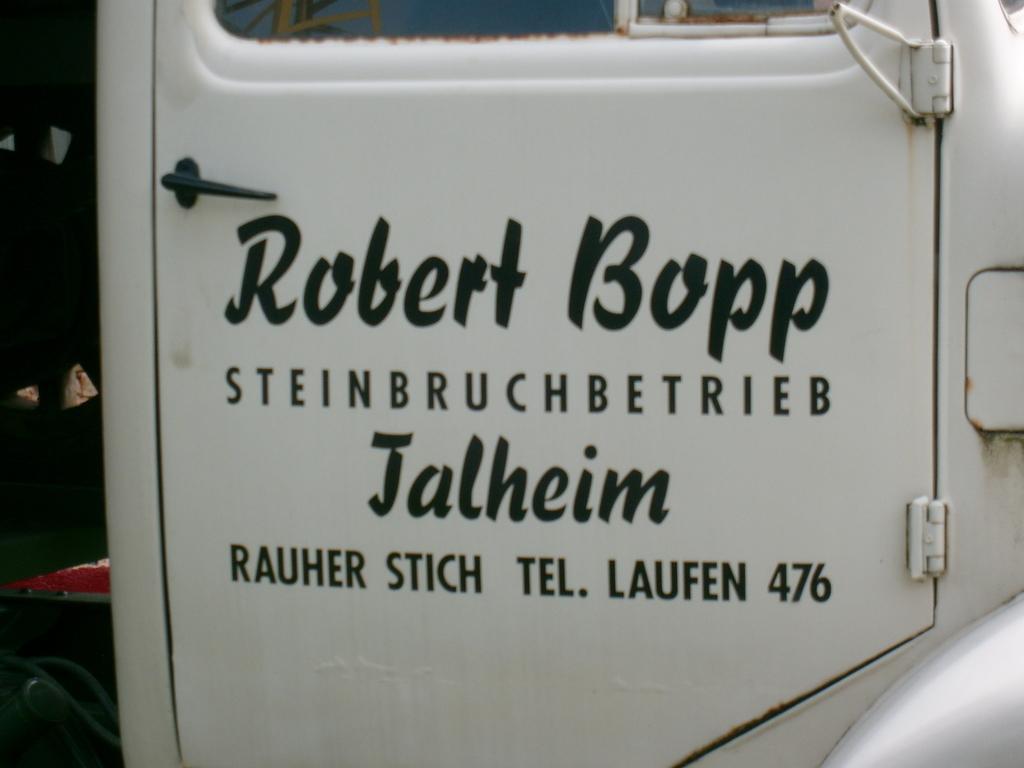Please provide a concise description of this image. In this image, we can see a white door with handle. Left side bottom, we can see some pipes. On the door, we can see some text. Top of the image, there is a glass. 